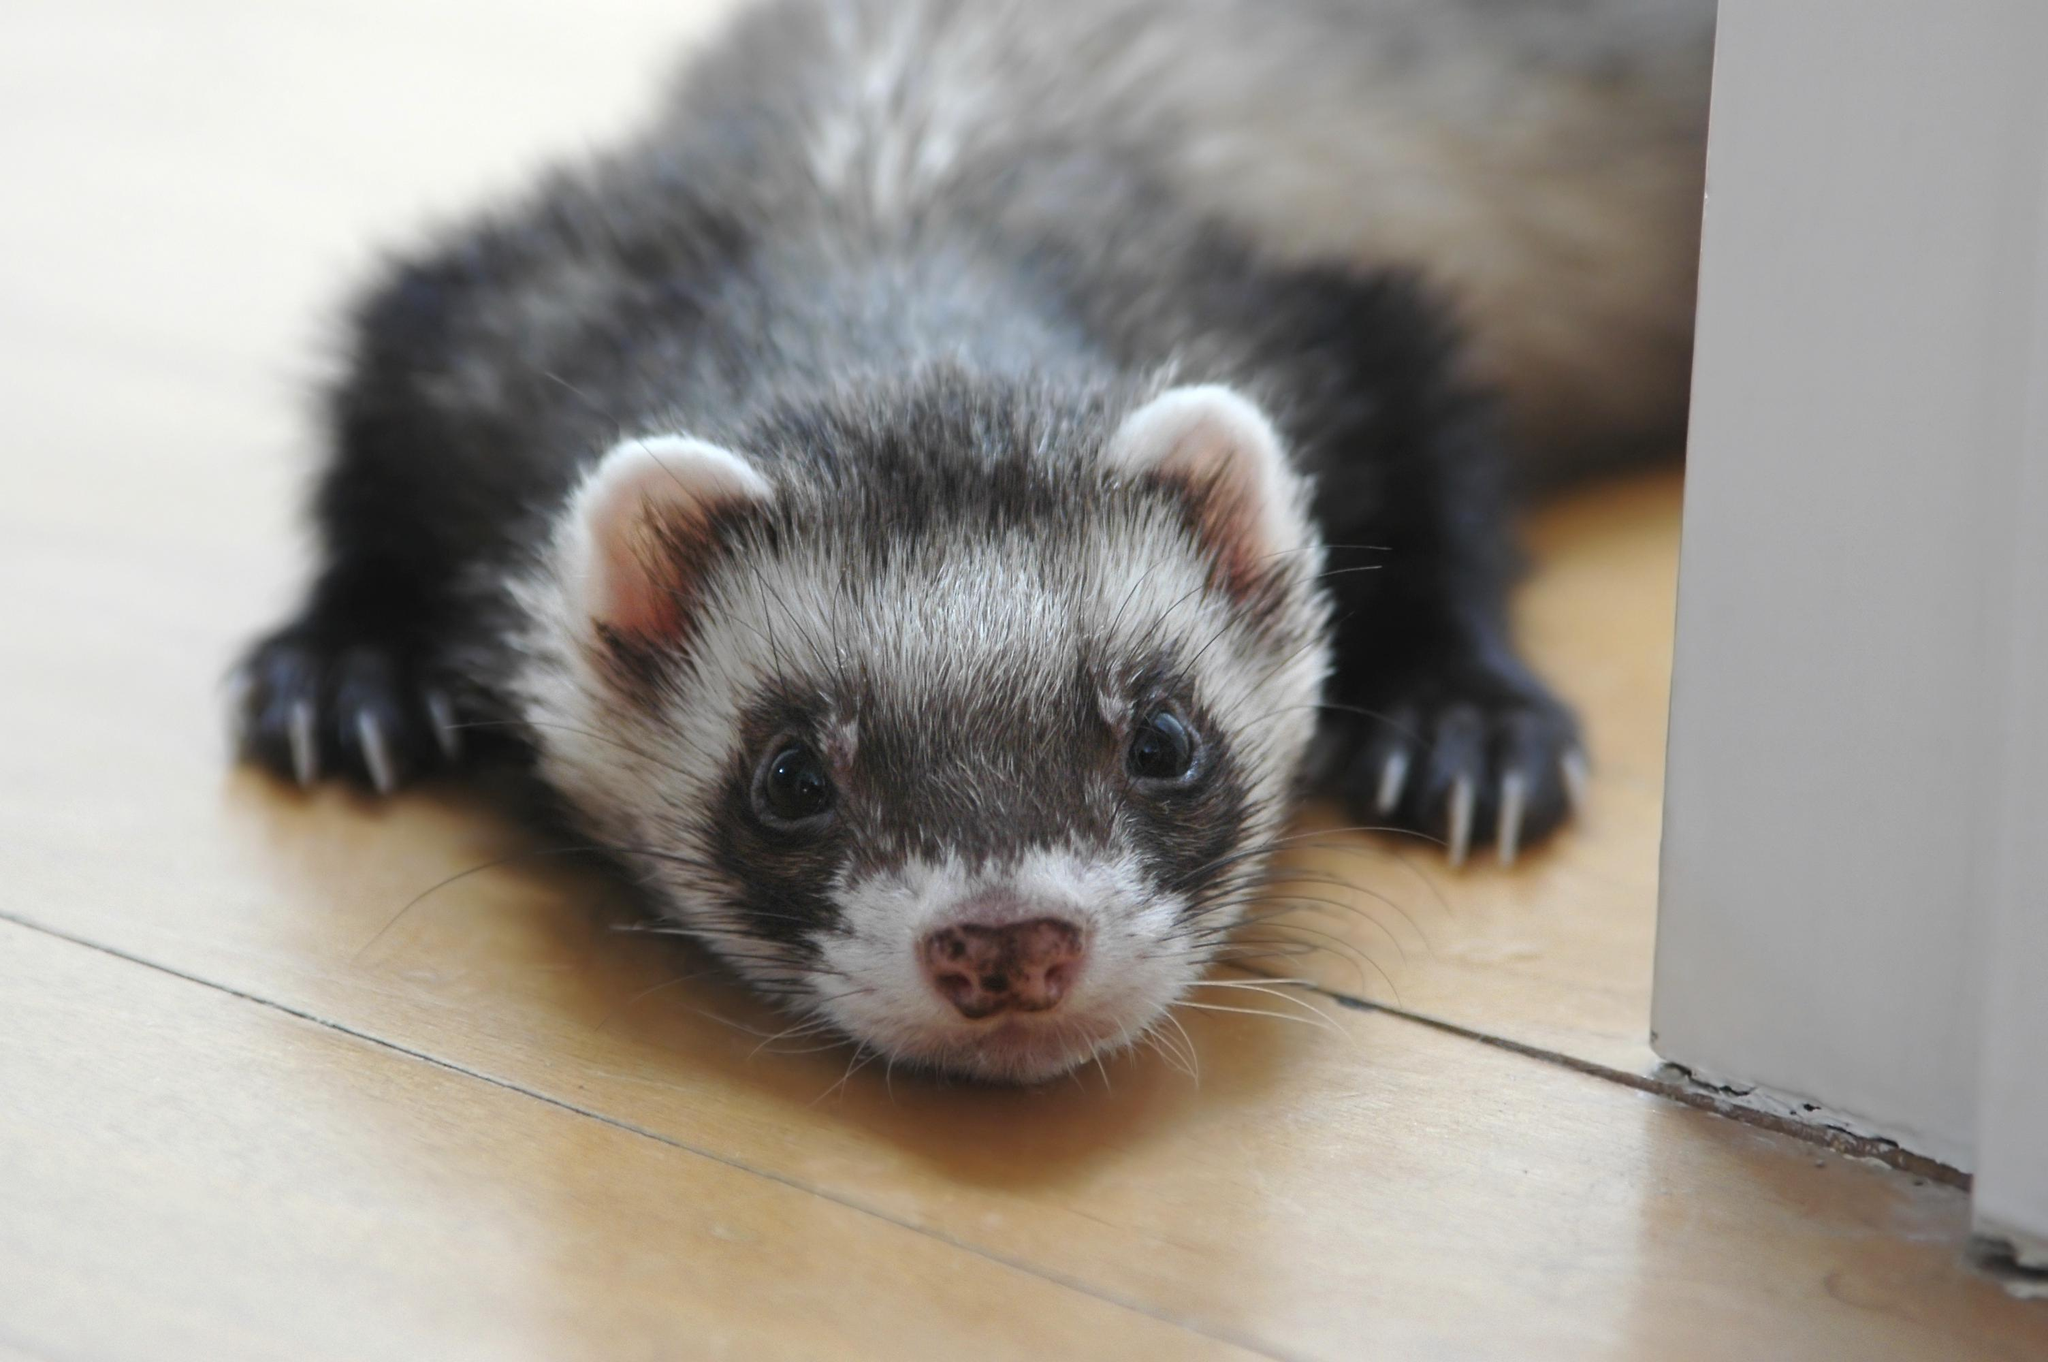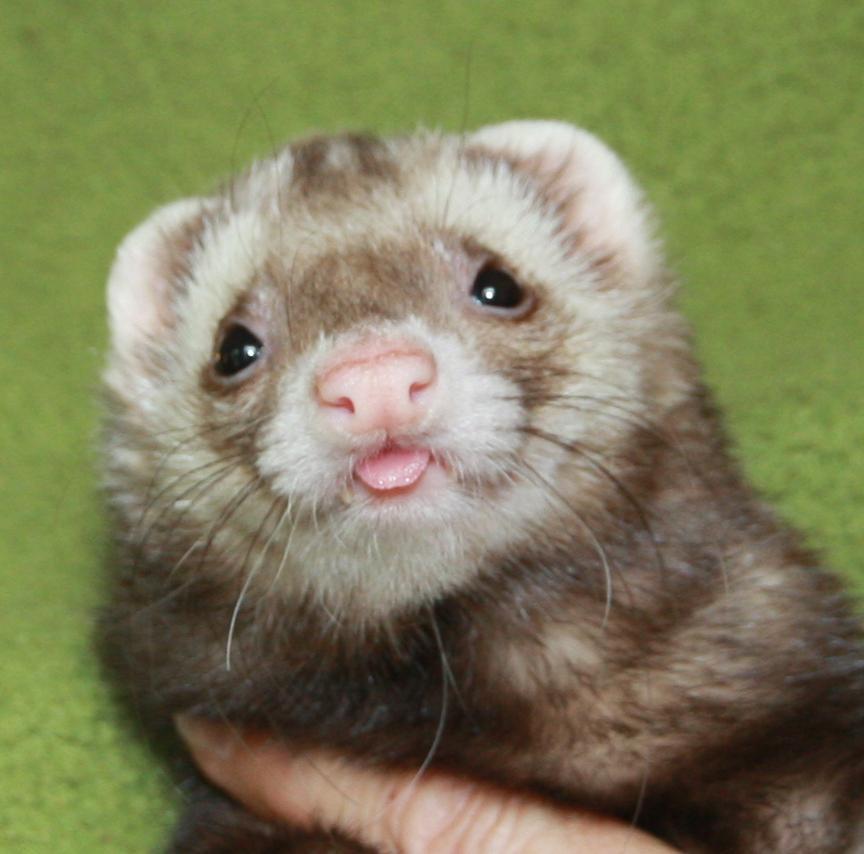The first image is the image on the left, the second image is the image on the right. Given the left and right images, does the statement "There are more animals in the image on the right." hold true? Answer yes or no. No. The first image is the image on the left, the second image is the image on the right. For the images shown, is this caption "The right image contains exactly two ferrets." true? Answer yes or no. No. 